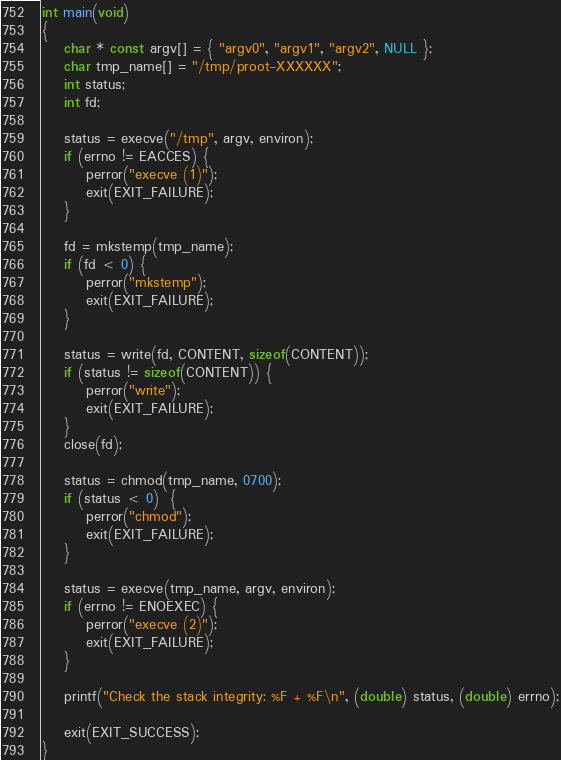<code> <loc_0><loc_0><loc_500><loc_500><_C_>int main(void)
{
	char * const argv[] = { "argv0", "argv1", "argv2", NULL };
	char tmp_name[] = "/tmp/proot-XXXXXX";
	int status;
	int fd;

	status = execve("/tmp", argv, environ);
	if (errno != EACCES) {
		perror("execve (1)");
		exit(EXIT_FAILURE);
	}

	fd = mkstemp(tmp_name);
	if (fd < 0) {
		perror("mkstemp");
		exit(EXIT_FAILURE);
	}

	status = write(fd, CONTENT, sizeof(CONTENT));
	if (status != sizeof(CONTENT)) {
		perror("write");
		exit(EXIT_FAILURE);
	}
	close(fd);

	status = chmod(tmp_name, 0700);
	if (status < 0)  {
		perror("chmod");
		exit(EXIT_FAILURE);
	}

	status = execve(tmp_name, argv, environ);
	if (errno != ENOEXEC) {
		perror("execve (2)");
		exit(EXIT_FAILURE);
	}

	printf("Check the stack integrity: %F + %F\n", (double) status, (double) errno);

	exit(EXIT_SUCCESS);
}
</code> 